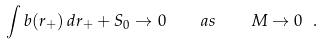Convert formula to latex. <formula><loc_0><loc_0><loc_500><loc_500>\int b ( r _ { + } ) \, d r _ { + } + S _ { 0 } \to 0 \quad a s \quad M \to 0 \ .</formula> 